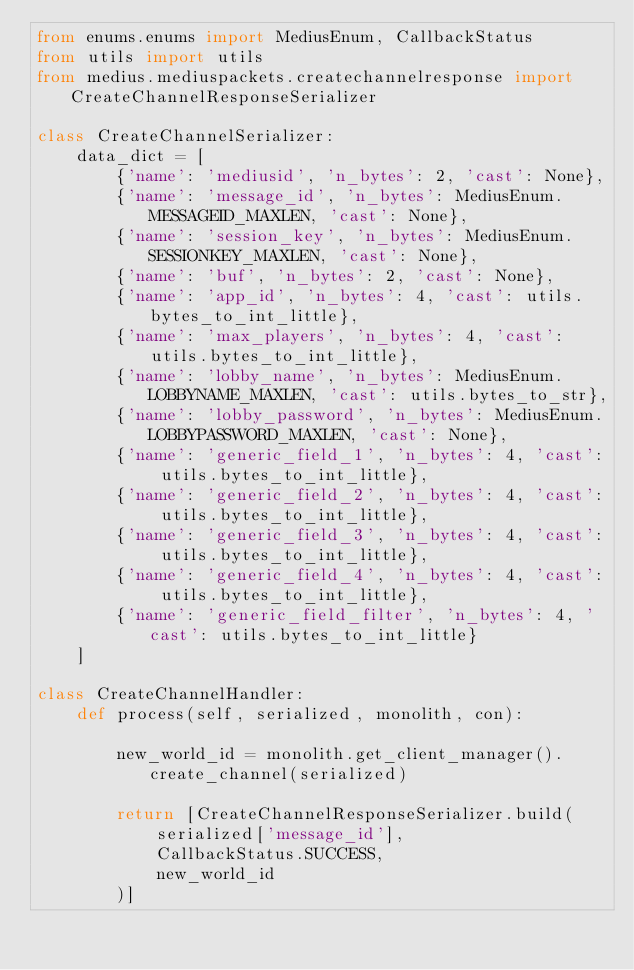Convert code to text. <code><loc_0><loc_0><loc_500><loc_500><_Python_>from enums.enums import MediusEnum, CallbackStatus
from utils import utils
from medius.mediuspackets.createchannelresponse import CreateChannelResponseSerializer

class CreateChannelSerializer:
    data_dict = [
        {'name': 'mediusid', 'n_bytes': 2, 'cast': None},
        {'name': 'message_id', 'n_bytes': MediusEnum.MESSAGEID_MAXLEN, 'cast': None},
        {'name': 'session_key', 'n_bytes': MediusEnum.SESSIONKEY_MAXLEN, 'cast': None},
        {'name': 'buf', 'n_bytes': 2, 'cast': None},
        {'name': 'app_id', 'n_bytes': 4, 'cast': utils.bytes_to_int_little},
        {'name': 'max_players', 'n_bytes': 4, 'cast': utils.bytes_to_int_little},
        {'name': 'lobby_name', 'n_bytes': MediusEnum.LOBBYNAME_MAXLEN, 'cast': utils.bytes_to_str},
        {'name': 'lobby_password', 'n_bytes': MediusEnum.LOBBYPASSWORD_MAXLEN, 'cast': None},
        {'name': 'generic_field_1', 'n_bytes': 4, 'cast': utils.bytes_to_int_little},
        {'name': 'generic_field_2', 'n_bytes': 4, 'cast': utils.bytes_to_int_little},
        {'name': 'generic_field_3', 'n_bytes': 4, 'cast': utils.bytes_to_int_little},
        {'name': 'generic_field_4', 'n_bytes': 4, 'cast': utils.bytes_to_int_little},
        {'name': 'generic_field_filter', 'n_bytes': 4, 'cast': utils.bytes_to_int_little}
    ]

class CreateChannelHandler:
    def process(self, serialized, monolith, con):

        new_world_id = monolith.get_client_manager().create_channel(serialized)

        return [CreateChannelResponseSerializer.build(
            serialized['message_id'],
            CallbackStatus.SUCCESS,
            new_world_id
        )]
</code> 